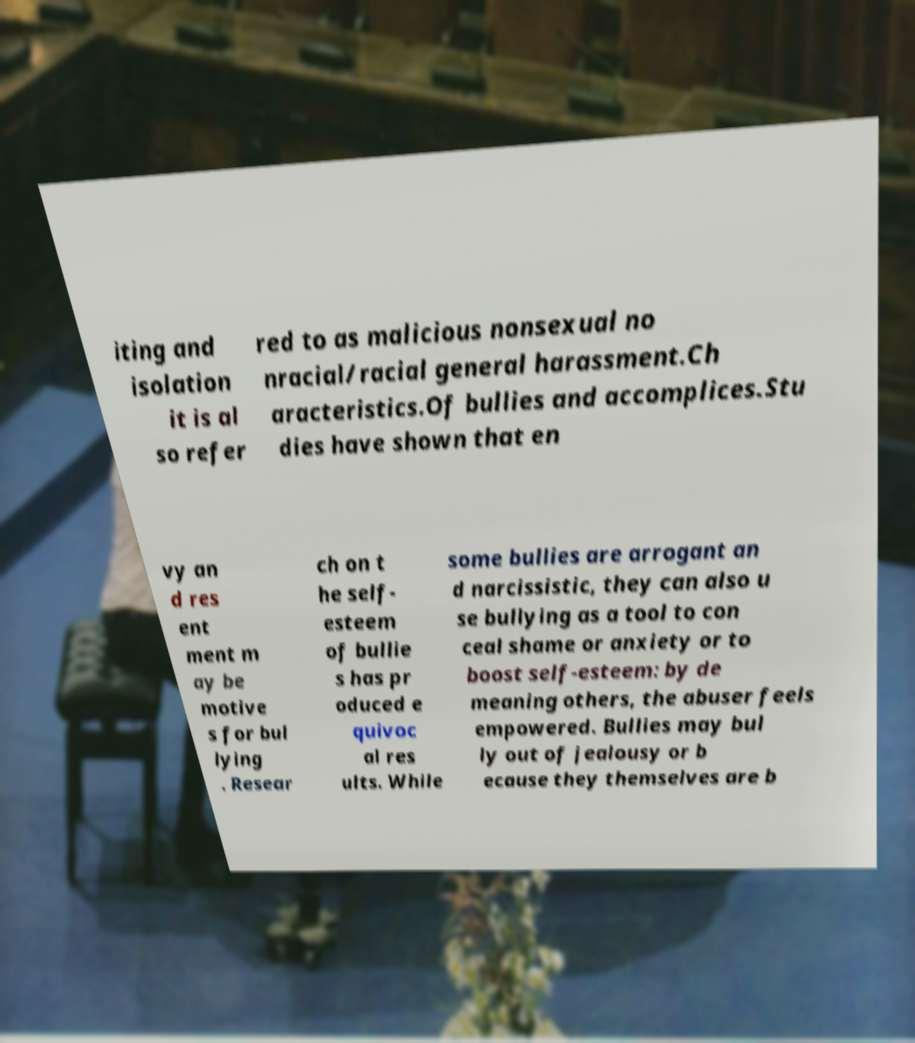Could you extract and type out the text from this image? iting and isolation it is al so refer red to as malicious nonsexual no nracial/racial general harassment.Ch aracteristics.Of bullies and accomplices.Stu dies have shown that en vy an d res ent ment m ay be motive s for bul lying . Resear ch on t he self- esteem of bullie s has pr oduced e quivoc al res ults. While some bullies are arrogant an d narcissistic, they can also u se bullying as a tool to con ceal shame or anxiety or to boost self-esteem: by de meaning others, the abuser feels empowered. Bullies may bul ly out of jealousy or b ecause they themselves are b 